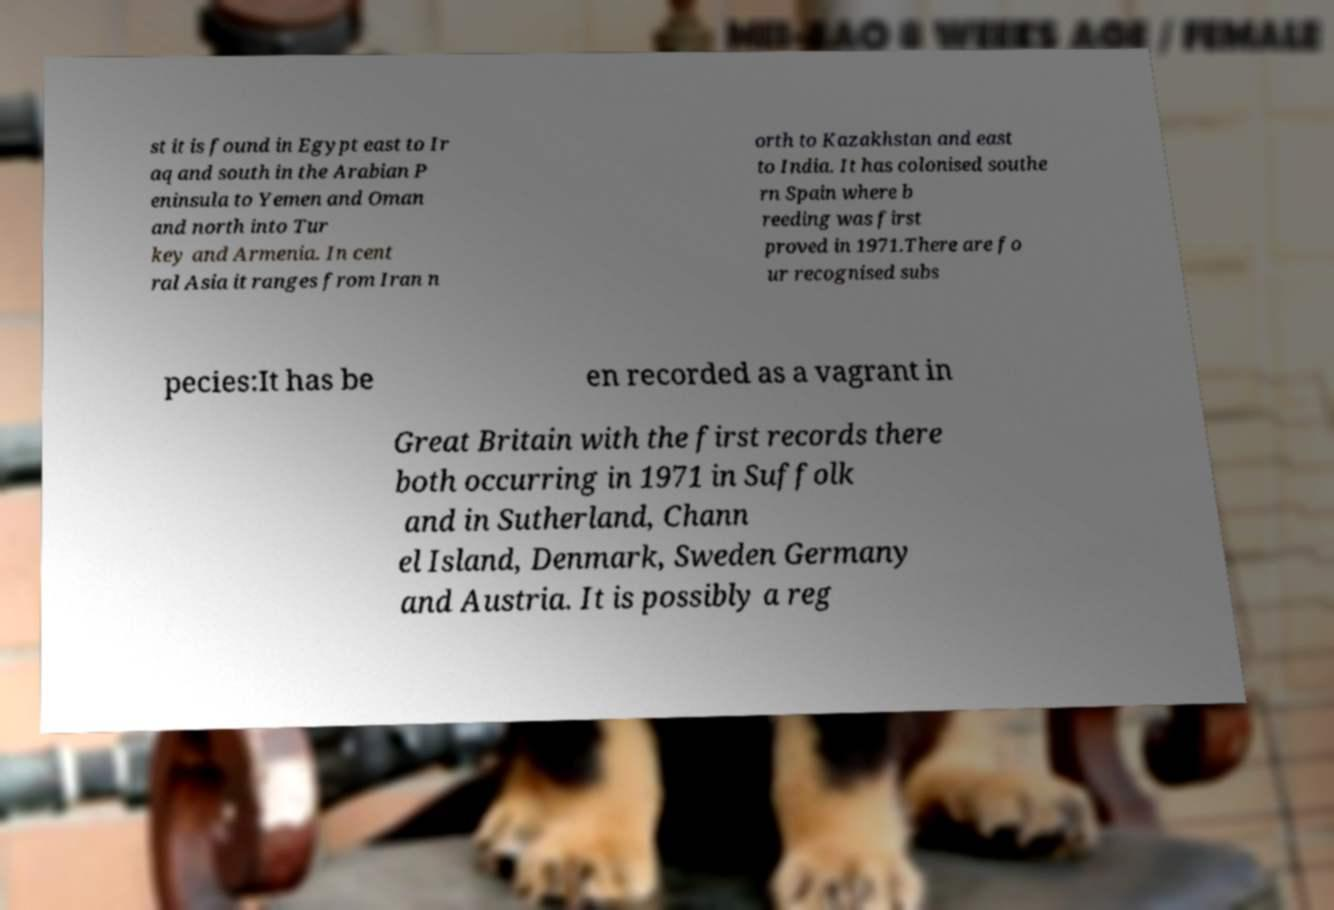Can you accurately transcribe the text from the provided image for me? st it is found in Egypt east to Ir aq and south in the Arabian P eninsula to Yemen and Oman and north into Tur key and Armenia. In cent ral Asia it ranges from Iran n orth to Kazakhstan and east to India. It has colonised southe rn Spain where b reeding was first proved in 1971.There are fo ur recognised subs pecies:It has be en recorded as a vagrant in Great Britain with the first records there both occurring in 1971 in Suffolk and in Sutherland, Chann el Island, Denmark, Sweden Germany and Austria. It is possibly a reg 